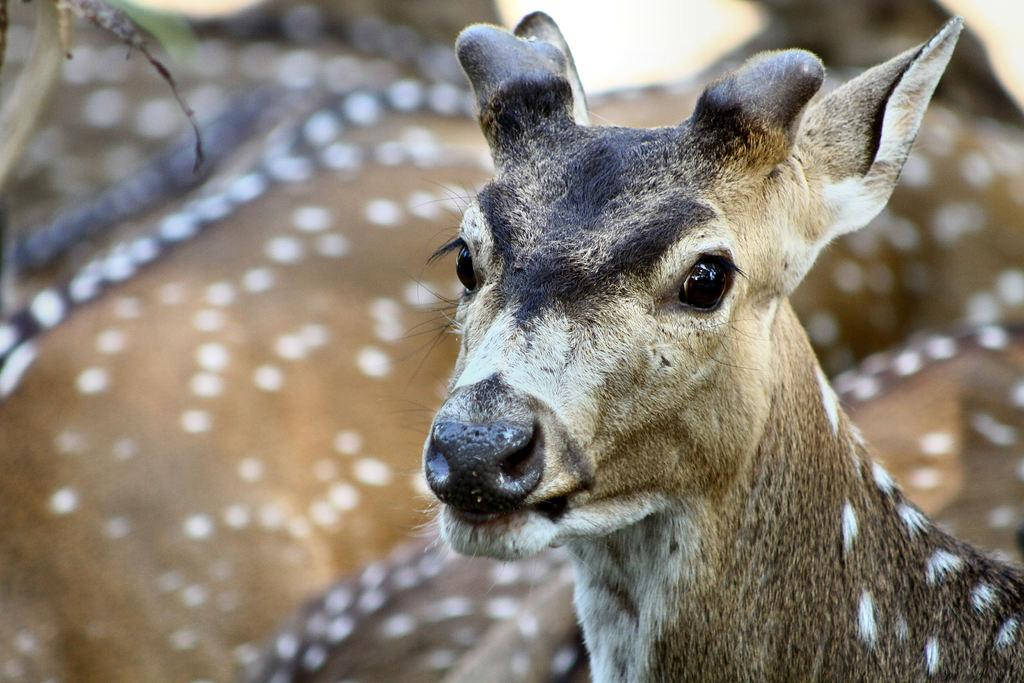What type of animals can be seen in the image? There are a few deer in the image. What type of instrument is being played by the deer in the image? There is no instrument present in the image, as it features a few deer and no musical instruments. 